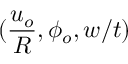<formula> <loc_0><loc_0><loc_500><loc_500>( \frac { u _ { o } } { R } , \phi _ { o } , w / t )</formula> 